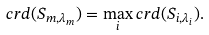<formula> <loc_0><loc_0><loc_500><loc_500>c r d ( S _ { m , \lambda _ { m } } ) = \max _ { i } c r d ( S _ { i , \lambda _ { i } } ) .</formula> 